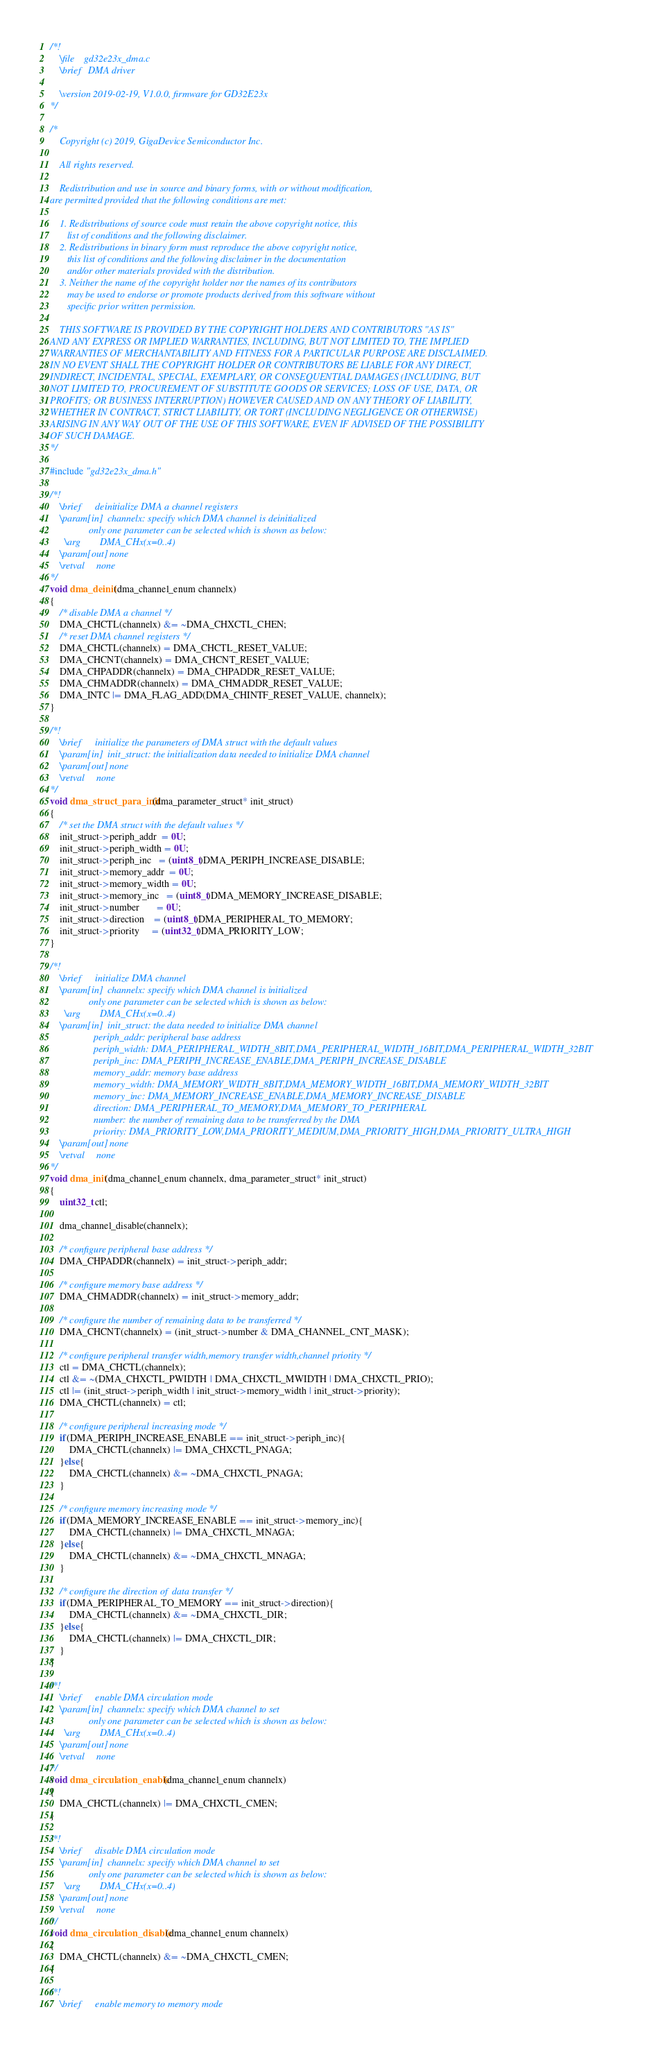<code> <loc_0><loc_0><loc_500><loc_500><_C_>/*!
    \file    gd32e23x_dma.c
    \brief   DMA driver
    
    \version 2019-02-19, V1.0.0, firmware for GD32E23x
*/

/*
    Copyright (c) 2019, GigaDevice Semiconductor Inc.

    All rights reserved.

    Redistribution and use in source and binary forms, with or without modification, 
are permitted provided that the following conditions are met:

    1. Redistributions of source code must retain the above copyright notice, this 
       list of conditions and the following disclaimer.
    2. Redistributions in binary form must reproduce the above copyright notice, 
       this list of conditions and the following disclaimer in the documentation 
       and/or other materials provided with the distribution.
    3. Neither the name of the copyright holder nor the names of its contributors 
       may be used to endorse or promote products derived from this software without 
       specific prior written permission.

    THIS SOFTWARE IS PROVIDED BY THE COPYRIGHT HOLDERS AND CONTRIBUTORS "AS IS" 
AND ANY EXPRESS OR IMPLIED WARRANTIES, INCLUDING, BUT NOT LIMITED TO, THE IMPLIED 
WARRANTIES OF MERCHANTABILITY AND FITNESS FOR A PARTICULAR PURPOSE ARE DISCLAIMED. 
IN NO EVENT SHALL THE COPYRIGHT HOLDER OR CONTRIBUTORS BE LIABLE FOR ANY DIRECT, 
INDIRECT, INCIDENTAL, SPECIAL, EXEMPLARY, OR CONSEQUENTIAL DAMAGES (INCLUDING, BUT 
NOT LIMITED TO, PROCUREMENT OF SUBSTITUTE GOODS OR SERVICES; LOSS OF USE, DATA, OR 
PROFITS; OR BUSINESS INTERRUPTION) HOWEVER CAUSED AND ON ANY THEORY OF LIABILITY, 
WHETHER IN CONTRACT, STRICT LIABILITY, OR TORT (INCLUDING NEGLIGENCE OR OTHERWISE) 
ARISING IN ANY WAY OUT OF THE USE OF THIS SOFTWARE, EVEN IF ADVISED OF THE POSSIBILITY 
OF SUCH DAMAGE.
*/

#include "gd32e23x_dma.h"

/*!
    \brief      deinitialize DMA a channel registers 
    \param[in]  channelx: specify which DMA channel is deinitialized
                only one parameter can be selected which is shown as below:
      \arg        DMA_CHx(x=0..4)
    \param[out] none
    \retval     none
*/
void dma_deinit(dma_channel_enum channelx)
{
    /* disable DMA a channel */
    DMA_CHCTL(channelx) &= ~DMA_CHXCTL_CHEN;
    /* reset DMA channel registers */
    DMA_CHCTL(channelx) = DMA_CHCTL_RESET_VALUE;
    DMA_CHCNT(channelx) = DMA_CHCNT_RESET_VALUE;
    DMA_CHPADDR(channelx) = DMA_CHPADDR_RESET_VALUE;
    DMA_CHMADDR(channelx) = DMA_CHMADDR_RESET_VALUE;
    DMA_INTC |= DMA_FLAG_ADD(DMA_CHINTF_RESET_VALUE, channelx);
}

/*!
    \brief      initialize the parameters of DMA struct with the default values
    \param[in]  init_struct: the initialization data needed to initialize DMA channel
    \param[out] none
    \retval     none
*/
void dma_struct_para_init(dma_parameter_struct* init_struct)
{
    /* set the DMA struct with the default values */
    init_struct->periph_addr  = 0U;
    init_struct->periph_width = 0U; 
    init_struct->periph_inc   = (uint8_t)DMA_PERIPH_INCREASE_DISABLE;
    init_struct->memory_addr  = 0U;
    init_struct->memory_width = 0U;
    init_struct->memory_inc   = (uint8_t)DMA_MEMORY_INCREASE_DISABLE;
    init_struct->number       = 0U;
    init_struct->direction    = (uint8_t)DMA_PERIPHERAL_TO_MEMORY;
    init_struct->priority     = (uint32_t)DMA_PRIORITY_LOW;
}

/*!
    \brief      initialize DMA channel 
    \param[in]  channelx: specify which DMA channel is initialized
                only one parameter can be selected which is shown as below:
      \arg        DMA_CHx(x=0..4)
    \param[in]  init_struct: the data needed to initialize DMA channel
                  periph_addr: peripheral base address
                  periph_width: DMA_PERIPHERAL_WIDTH_8BIT,DMA_PERIPHERAL_WIDTH_16BIT,DMA_PERIPHERAL_WIDTH_32BIT
                  periph_inc: DMA_PERIPH_INCREASE_ENABLE,DMA_PERIPH_INCREASE_DISABLE 
                  memory_addr: memory base address
                  memory_width: DMA_MEMORY_WIDTH_8BIT,DMA_MEMORY_WIDTH_16BIT,DMA_MEMORY_WIDTH_32BIT
                  memory_inc: DMA_MEMORY_INCREASE_ENABLE,DMA_MEMORY_INCREASE_DISABLE
                  direction: DMA_PERIPHERAL_TO_MEMORY,DMA_MEMORY_TO_PERIPHERAL
                  number: the number of remaining data to be transferred by the DMA
                  priority: DMA_PRIORITY_LOW,DMA_PRIORITY_MEDIUM,DMA_PRIORITY_HIGH,DMA_PRIORITY_ULTRA_HIGH
    \param[out] none
    \retval     none
*/
void dma_init(dma_channel_enum channelx, dma_parameter_struct* init_struct)
{
    uint32_t ctl;
    
    dma_channel_disable(channelx);
    
    /* configure peripheral base address */
    DMA_CHPADDR(channelx) = init_struct->periph_addr;
    
    /* configure memory base address */
    DMA_CHMADDR(channelx) = init_struct->memory_addr;
    
    /* configure the number of remaining data to be transferred */
    DMA_CHCNT(channelx) = (init_struct->number & DMA_CHANNEL_CNT_MASK);
    
    /* configure peripheral transfer width,memory transfer width,channel priotity */
    ctl = DMA_CHCTL(channelx);
    ctl &= ~(DMA_CHXCTL_PWIDTH | DMA_CHXCTL_MWIDTH | DMA_CHXCTL_PRIO);
    ctl |= (init_struct->periph_width | init_struct->memory_width | init_struct->priority);
    DMA_CHCTL(channelx) = ctl;

    /* configure peripheral increasing mode */
    if(DMA_PERIPH_INCREASE_ENABLE == init_struct->periph_inc){
        DMA_CHCTL(channelx) |= DMA_CHXCTL_PNAGA;
    }else{
        DMA_CHCTL(channelx) &= ~DMA_CHXCTL_PNAGA;
    }

    /* configure memory increasing mode */
    if(DMA_MEMORY_INCREASE_ENABLE == init_struct->memory_inc){
        DMA_CHCTL(channelx) |= DMA_CHXCTL_MNAGA;
    }else{
        DMA_CHCTL(channelx) &= ~DMA_CHXCTL_MNAGA;
    }
    
    /* configure the direction of  data transfer */
    if(DMA_PERIPHERAL_TO_MEMORY == init_struct->direction){
        DMA_CHCTL(channelx) &= ~DMA_CHXCTL_DIR;
    }else{
        DMA_CHCTL(channelx) |= DMA_CHXCTL_DIR;
    } 
}

/*!
    \brief      enable DMA circulation mode  
    \param[in]  channelx: specify which DMA channel to set
                only one parameter can be selected which is shown as below:
      \arg        DMA_CHx(x=0..4)
    \param[out] none
    \retval     none 
*/
void dma_circulation_enable(dma_channel_enum channelx)
{
    DMA_CHCTL(channelx) |= DMA_CHXCTL_CMEN;
}

/*!
    \brief      disable DMA circulation mode  
    \param[in]  channelx: specify which DMA channel to set
                only one parameter can be selected which is shown as below:
      \arg        DMA_CHx(x=0..4)
    \param[out] none
    \retval     none 
*/
void dma_circulation_disable(dma_channel_enum channelx)
{
    DMA_CHCTL(channelx) &= ~DMA_CHXCTL_CMEN;
}

/*!
    \brief      enable memory to memory mode</code> 